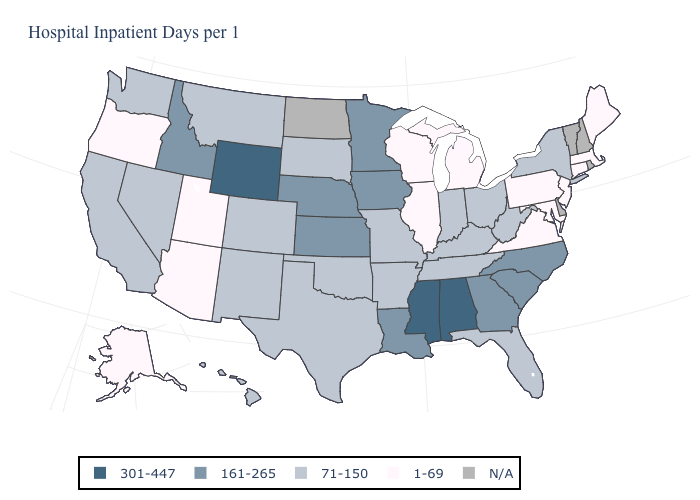What is the lowest value in the West?
Be succinct. 1-69. What is the value of Connecticut?
Be succinct. 1-69. What is the value of Illinois?
Be succinct. 1-69. Name the states that have a value in the range N/A?
Concise answer only. Delaware, New Hampshire, North Dakota, Rhode Island, Vermont. What is the lowest value in the USA?
Quick response, please. 1-69. What is the value of Texas?
Keep it brief. 71-150. Which states have the lowest value in the USA?
Write a very short answer. Alaska, Arizona, Connecticut, Illinois, Maine, Maryland, Massachusetts, Michigan, New Jersey, Oregon, Pennsylvania, Utah, Virginia, Wisconsin. What is the highest value in the South ?
Write a very short answer. 301-447. Which states have the lowest value in the West?
Write a very short answer. Alaska, Arizona, Oregon, Utah. What is the lowest value in states that border Arkansas?
Write a very short answer. 71-150. Name the states that have a value in the range 1-69?
Answer briefly. Alaska, Arizona, Connecticut, Illinois, Maine, Maryland, Massachusetts, Michigan, New Jersey, Oregon, Pennsylvania, Utah, Virginia, Wisconsin. What is the value of Idaho?
Quick response, please. 161-265. 